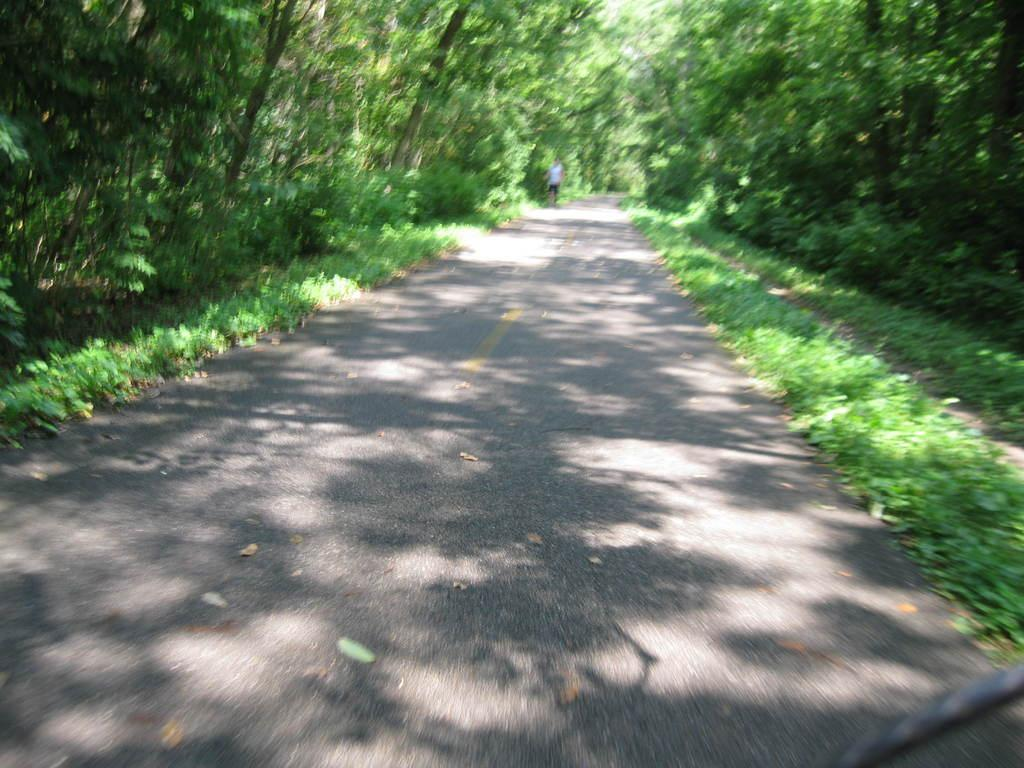What is the person in the image doing? The person is standing on the road in the image. What can be seen in the image besides the person? Plants and a group of trees are visible in the image. What type of rule is being enforced by the person in the image? There is no indication of any rule being enforced in the image. 